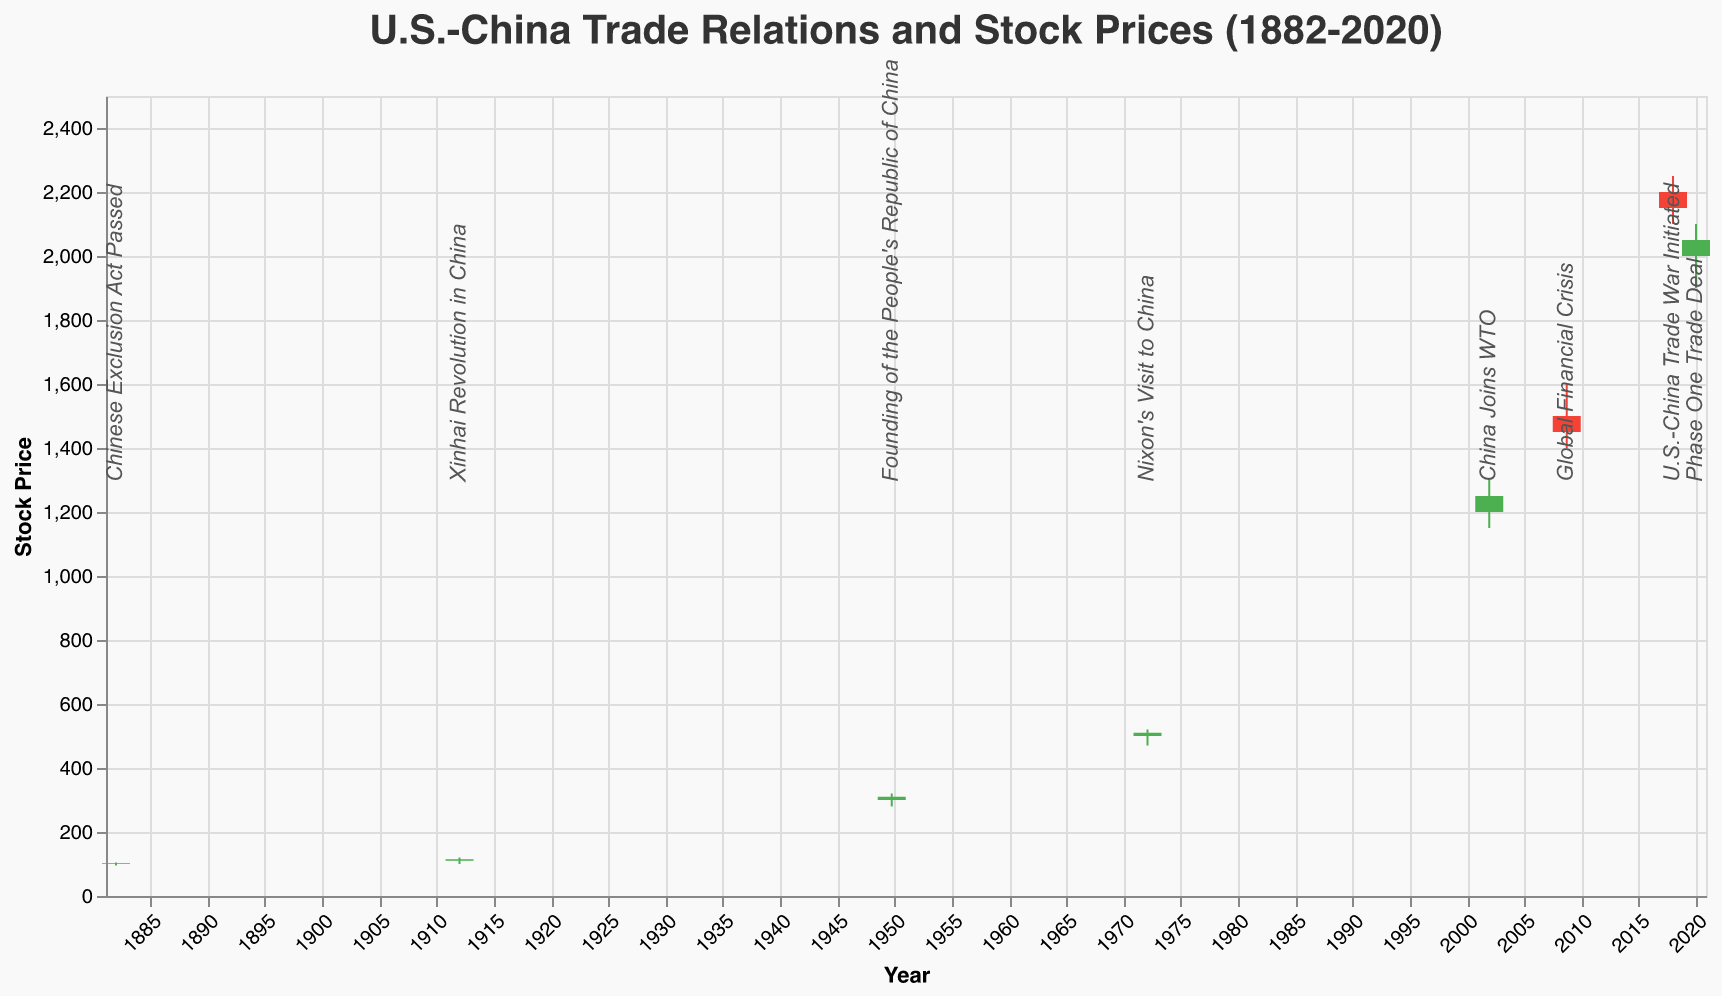What event corresponds to the highest high price and what was that price? The highest high price in the dataset is 2250, and it corresponds to the event "U.S.-China Trade War Initiated" on 2018-01-01. By examining the data for this date, it shows the matching high price.
Answer: U.S.-China Trade War Initiated, 2250 Which event corresponded to the greatest increase in stock price from open to close? To find the greatest increase, we need to calculate the difference between the close and open prices for each event. The largest increase is from the "Founding of the People's Republic of China", where the close price of 310 minus the open price of 300 gives an increase of 10.
Answer: Founding of the People's Republic of China, 10 What is the trend in stock prices around major U.S.-China political events? Analyzing events such as "Nixon's Visit to China" (1972), "China Joins WTO" (2001), "U.S.-China Trade War Initiated" (2018), we see a general upward trend in stock prices over time, despite fluctuations with each event. This can be deduced by the higher general values over successive significant dates.
Answer: Upward How did the stock price change immediately after the "Chinese Exclusion Act Passed"? Observing the "Chinese Exclusion Act Passed" event on 1882-01-01, the open price was 100 and the close was 102. This indicates a modest increase of 2 from open to close immediately after the event.
Answer: Increase by 2 What was the stock price on the date of the Global Financial Crisis, and how does it compare to the previous event in the dataset? On the date of the "Global Financial Crisis" (2008-09-15), the stock closed at 1450. The previous event was "China Joins WTO" on 2001-12-11, with a close price of 1250. The comparison indicates an increase in the close price by 200.
Answer: 1450, 200 Which event resulted in a decrease in stock price from open to close and by how much? By examining the open and close prices for each event, we find that the "Global Financial Crisis" resulted in a decrease. The open price was 1500, and the close price was 1450, resulting in a decrease of 50.
Answer: Global Financial Crisis, 50 How did the stock price react to Nixon's visit to China? Looking at "Nixon's Visit to China" on 1972-02-01, the open price was 500 and the close price was 510, indicating a small increase of 10. This shows a positive reaction in the stock price.
Answer: Increased by 10 What is the average stock price (close) on the major political events presented? To find the average close price, sum the close prices for all events and divide by the number of events: (102 + 115 + 310 + 510 + 1250 + 1450 + 2150 + 2050) / 8. The calculated average is (9747) / 8 = 1218.375.
Answer: 1218.375 Which events show a downward trend from open to close prices? Analyzing each event for open to close price trends, two events show decreases: "Global Financial Crisis" (1500 to 1450, a decrease of 50) and "U.S.-China Trade War Initiated" (2200 to 2150, a decrease of 50).
Answer: Global Financial Crisis, U.S.-China Trade War Initiated 